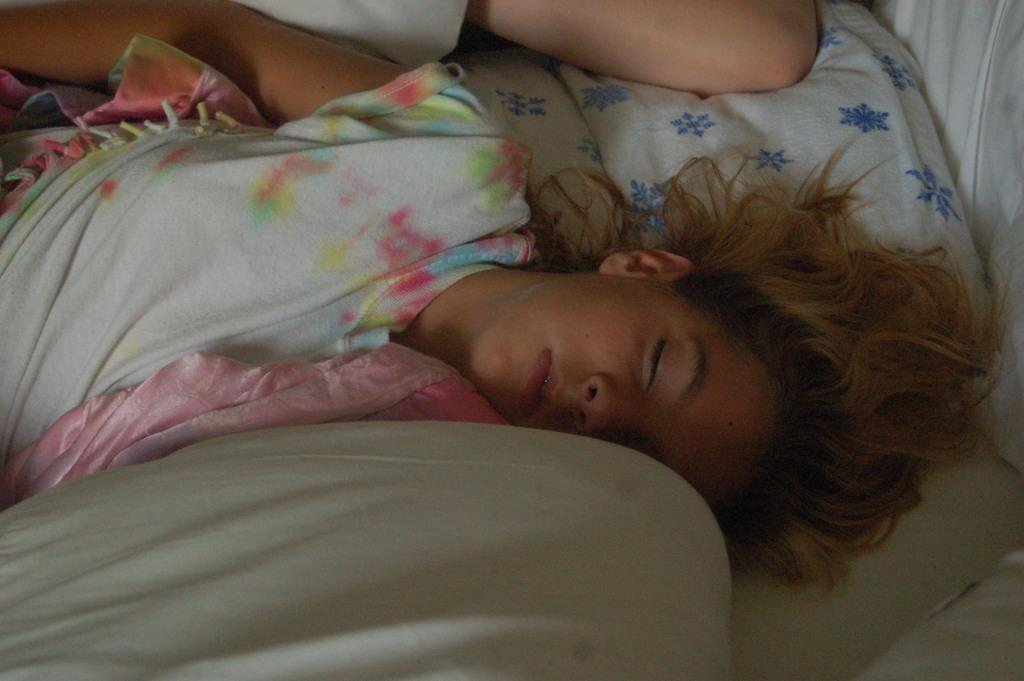How many people are in the image? There are two persons in the image. What are the two persons doing in the image? The two persons are lying on a bed. Where is the cave located in the image? There is no cave present in the image; it features two persons lying on a bed. Can you tell me how the two persons are joining hands in the image? There is no indication in the image that the two persons are joining hands, as they are lying on a bed. 